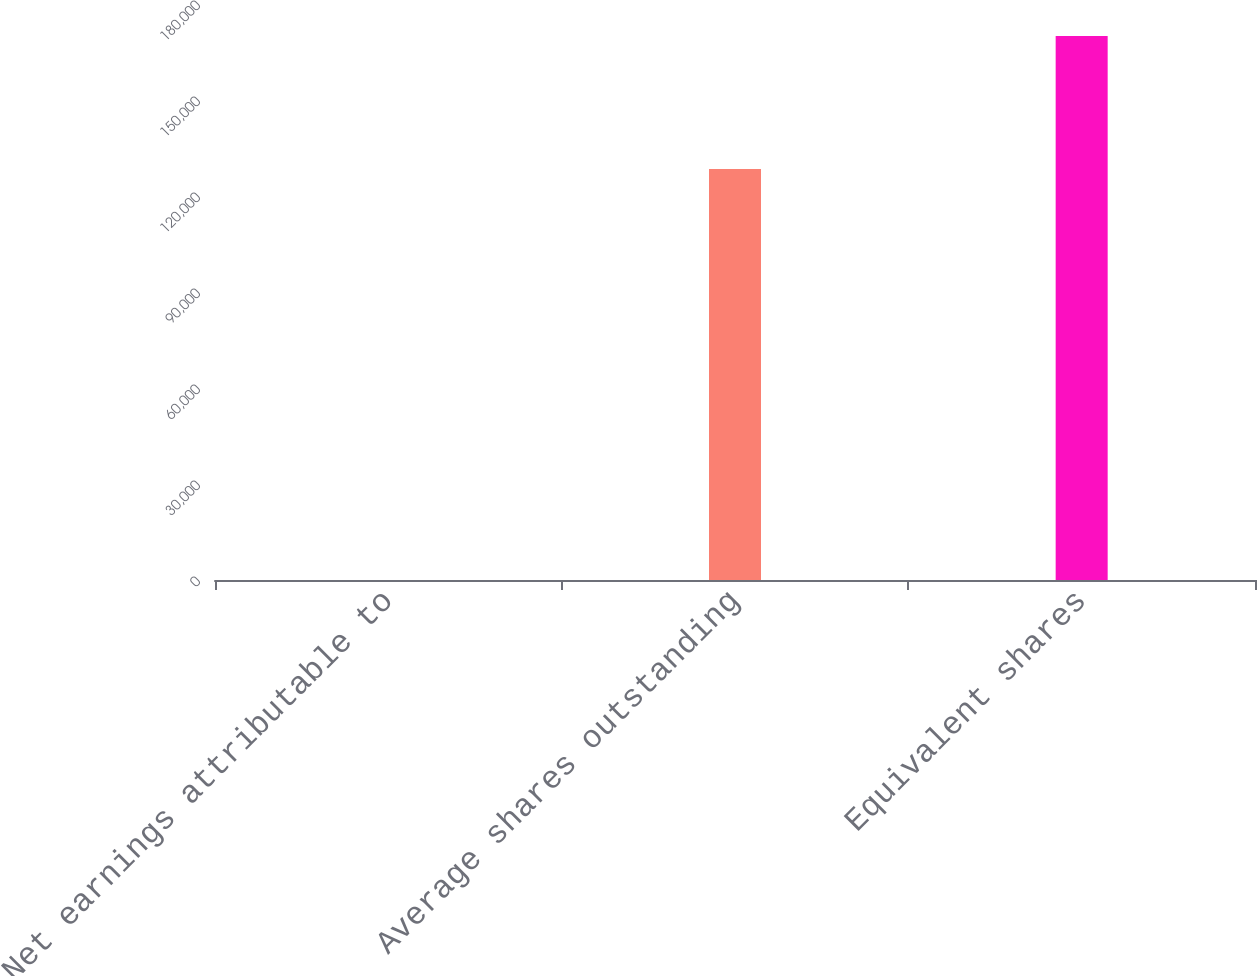Convert chart to OTSL. <chart><loc_0><loc_0><loc_500><loc_500><bar_chart><fcel>Net earnings attributable to<fcel>Average shares outstanding<fcel>Equivalent shares<nl><fcel>3.2<fcel>128411<fcel>170004<nl></chart> 